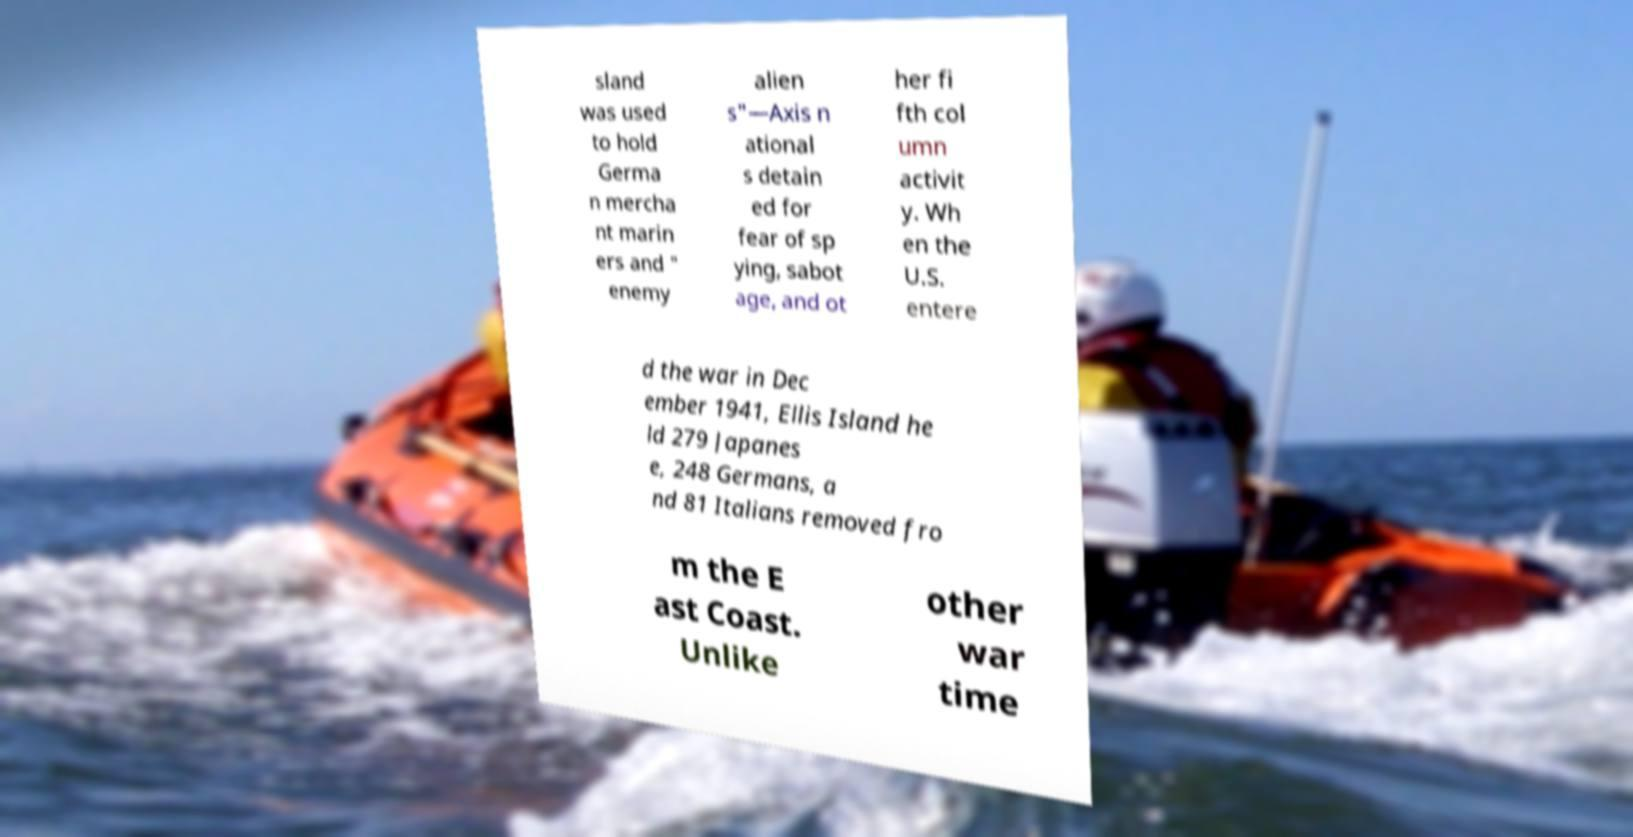What messages or text are displayed in this image? I need them in a readable, typed format. sland was used to hold Germa n mercha nt marin ers and " enemy alien s"—Axis n ational s detain ed for fear of sp ying, sabot age, and ot her fi fth col umn activit y. Wh en the U.S. entere d the war in Dec ember 1941, Ellis Island he ld 279 Japanes e, 248 Germans, a nd 81 Italians removed fro m the E ast Coast. Unlike other war time 